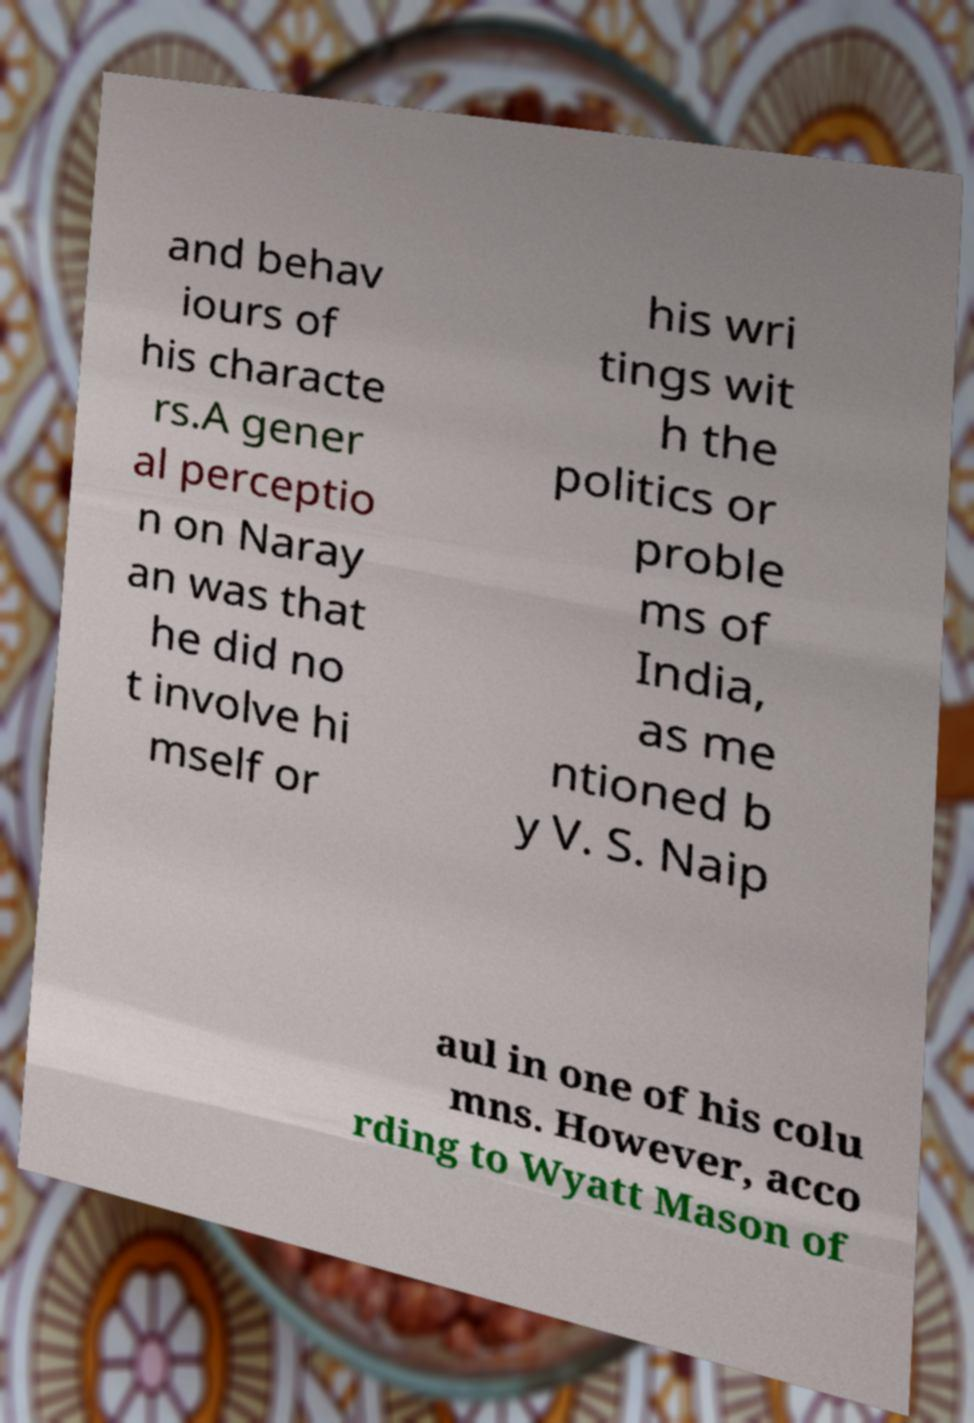What messages or text are displayed in this image? I need them in a readable, typed format. and behav iours of his characte rs.A gener al perceptio n on Naray an was that he did no t involve hi mself or his wri tings wit h the politics or proble ms of India, as me ntioned b y V. S. Naip aul in one of his colu mns. However, acco rding to Wyatt Mason of 